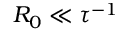<formula> <loc_0><loc_0><loc_500><loc_500>R _ { 0 } \ll \tau ^ { - 1 }</formula> 